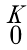Convert formula to latex. <formula><loc_0><loc_0><loc_500><loc_500>\begin{smallmatrix} K \\ 0 \end{smallmatrix}</formula> 